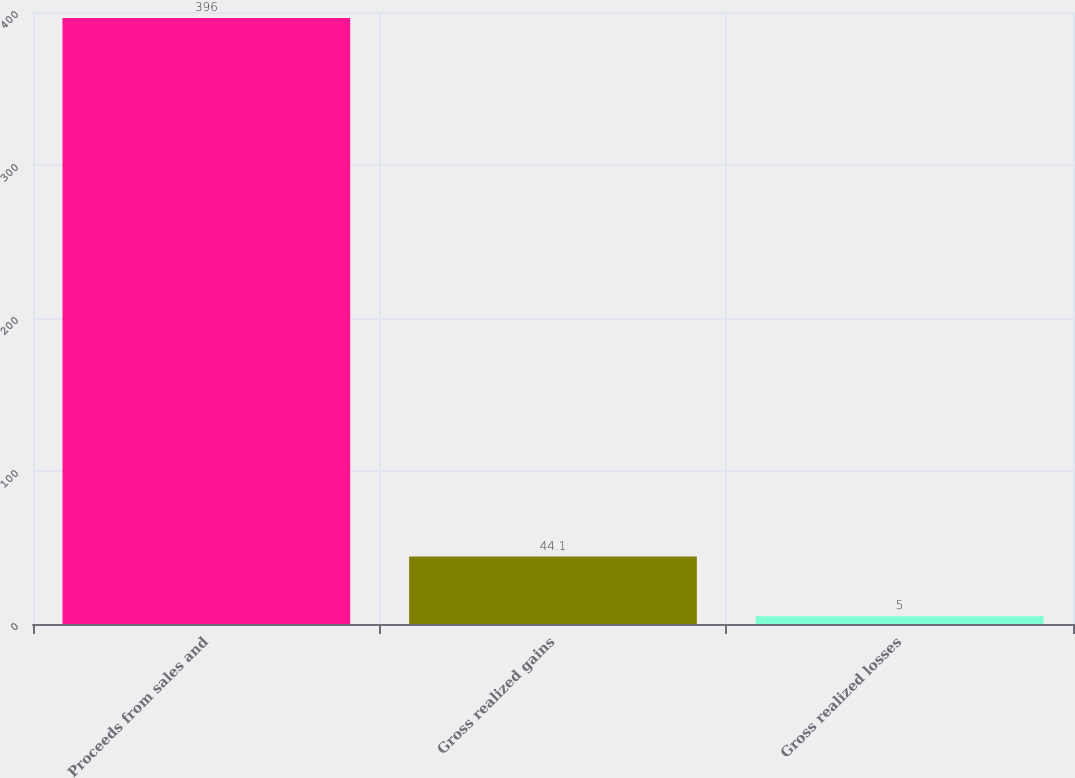<chart> <loc_0><loc_0><loc_500><loc_500><bar_chart><fcel>Proceeds from sales and<fcel>Gross realized gains<fcel>Gross realized losses<nl><fcel>396<fcel>44.1<fcel>5<nl></chart> 